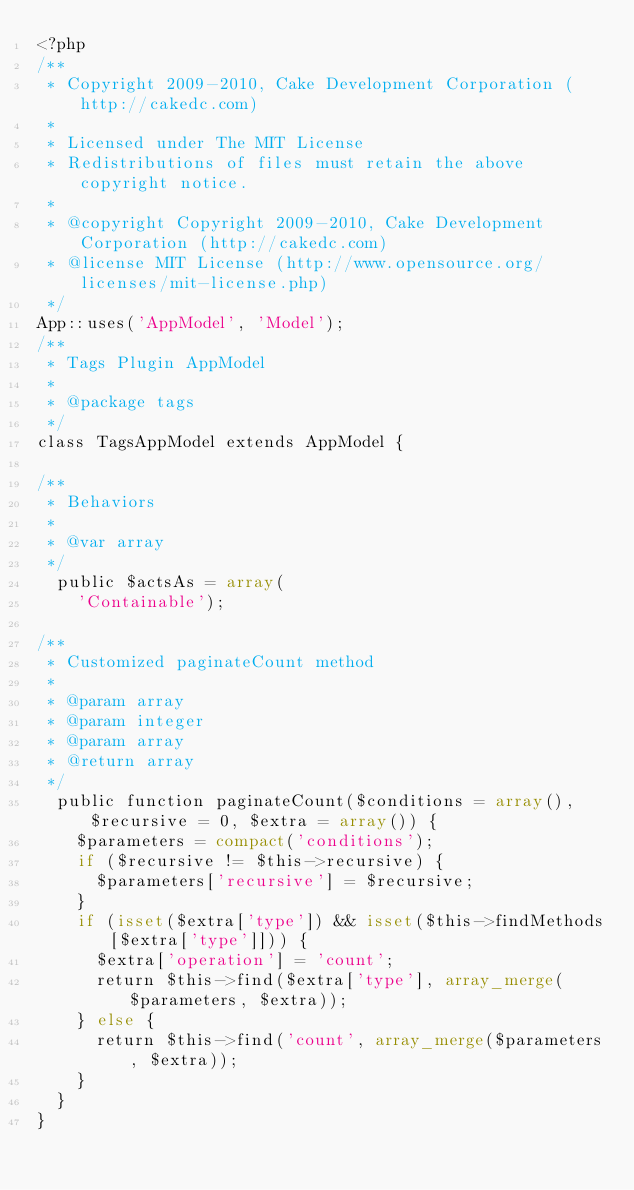<code> <loc_0><loc_0><loc_500><loc_500><_PHP_><?php
/**
 * Copyright 2009-2010, Cake Development Corporation (http://cakedc.com)
 *
 * Licensed under The MIT License
 * Redistributions of files must retain the above copyright notice.
 *
 * @copyright Copyright 2009-2010, Cake Development Corporation (http://cakedc.com)
 * @license MIT License (http://www.opensource.org/licenses/mit-license.php)
 */
App::uses('AppModel', 'Model');
/**
 * Tags Plugin AppModel
 *
 * @package tags
 */
class TagsAppModel extends AppModel {

/**
 * Behaviors
 *
 * @var array
 */
	public $actsAs = array(
		'Containable');

/**
 * Customized paginateCount method
 *
 * @param array
 * @param integer
 * @param array
 * @return array
 */
	public function paginateCount($conditions = array(), $recursive = 0, $extra = array()) {
		$parameters = compact('conditions');
		if ($recursive != $this->recursive) {
			$parameters['recursive'] = $recursive;
		}
		if (isset($extra['type']) && isset($this->findMethods[$extra['type']])) {
			$extra['operation'] = 'count';
			return $this->find($extra['type'], array_merge($parameters, $extra));
		} else {
			return $this->find('count', array_merge($parameters, $extra));
		}
	}
}
</code> 